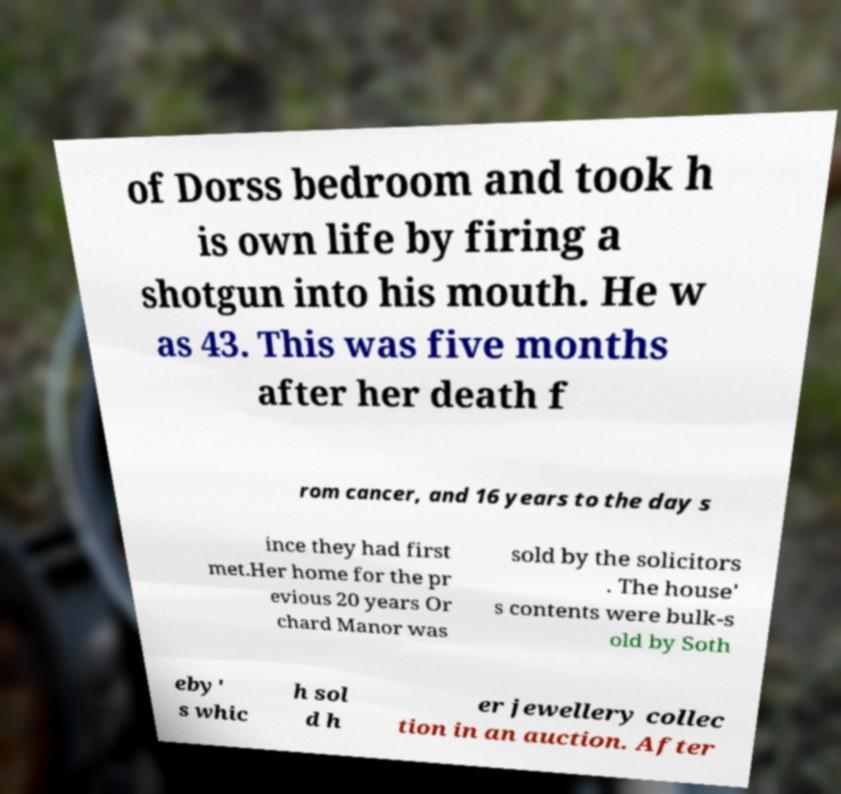Please identify and transcribe the text found in this image. of Dorss bedroom and took h is own life by firing a shotgun into his mouth. He w as 43. This was five months after her death f rom cancer, and 16 years to the day s ince they had first met.Her home for the pr evious 20 years Or chard Manor was sold by the solicitors . The house' s contents were bulk-s old by Soth eby' s whic h sol d h er jewellery collec tion in an auction. After 